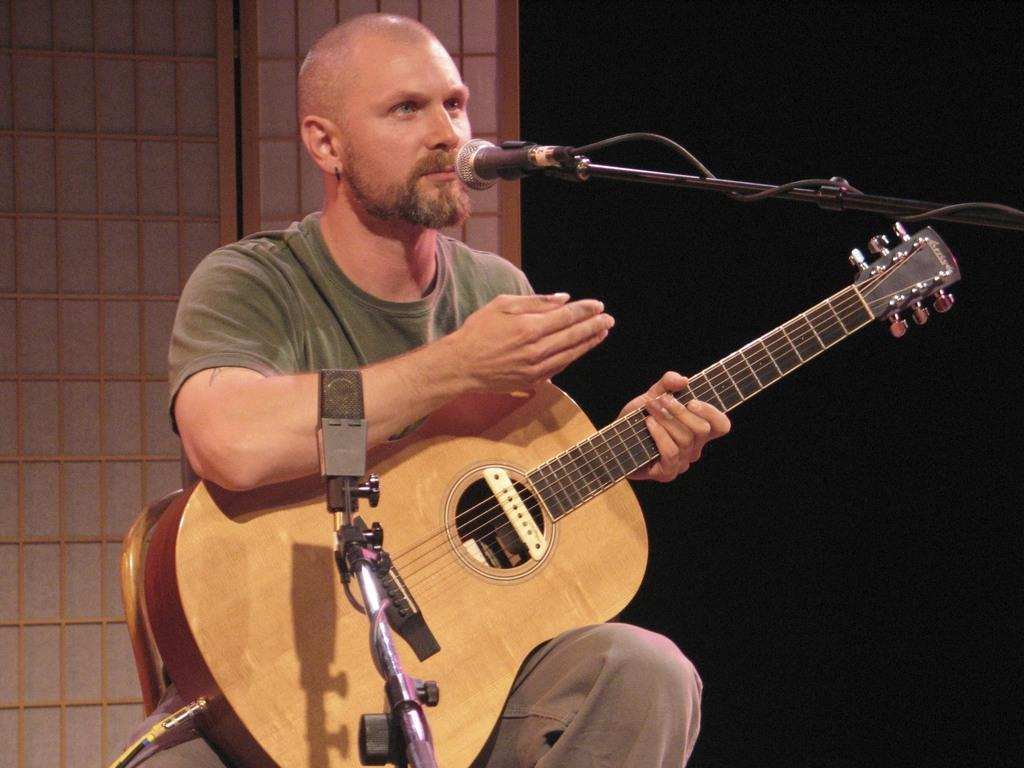What is the man in the image doing? The man is singing in the image. What object is in front of the man? There is a microphone in front of the man. What instrument is the man holding? The man is holding a guitar in his hand. Reasoning: Let's think step by step by step in order to produce the conversation. We start by identifying the main subject in the image, which is the man. Then, we describe what the man is doing, which is singing. Next, we mention the object in front of the man, which is the microphone. Finally, we identify the instrument the man is holding, which is a guitar. Each question is designed to elicit a specific detail about the image that is known from the provided facts. Absurd Question/Answer: What type of property does the man own in the image? There is no information about property ownership in the image. What advice is the man giving to the audience in the image? There is no indication that the man is giving advice in the image; he is singing. What type of glove is the man wearing on his left hand in the image? There is no glove visible on the man's hand in the image. 